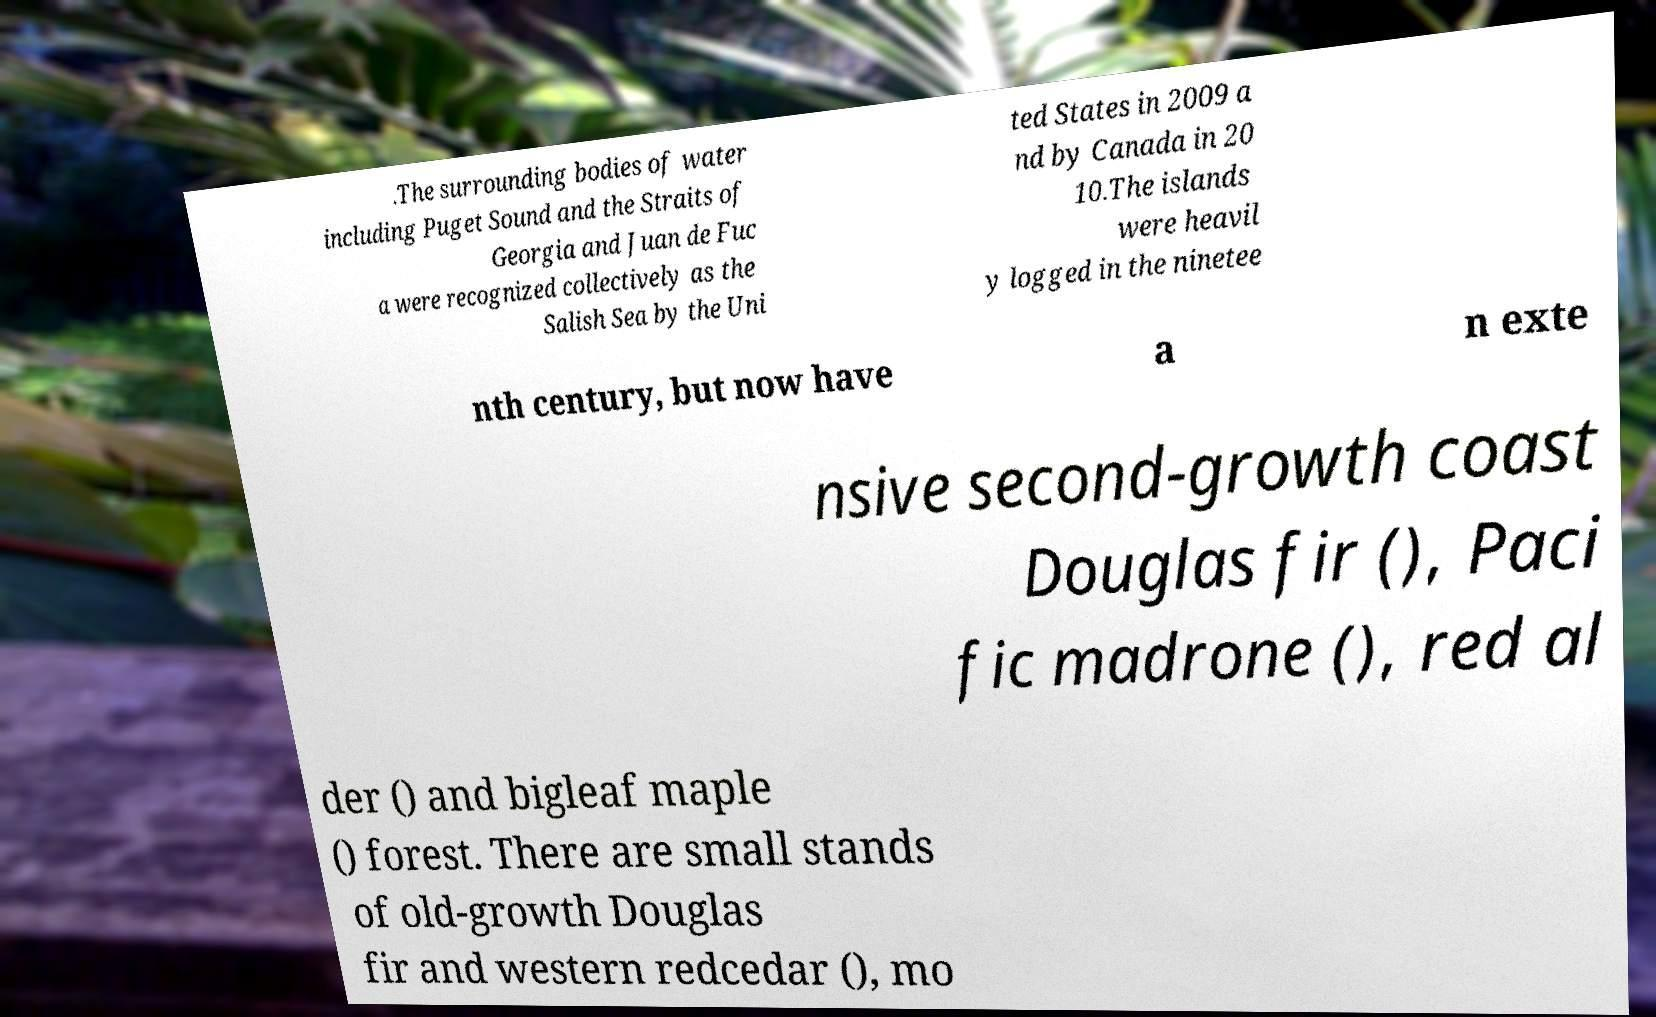For documentation purposes, I need the text within this image transcribed. Could you provide that? .The surrounding bodies of water including Puget Sound and the Straits of Georgia and Juan de Fuc a were recognized collectively as the Salish Sea by the Uni ted States in 2009 a nd by Canada in 20 10.The islands were heavil y logged in the ninetee nth century, but now have a n exte nsive second-growth coast Douglas fir (), Paci fic madrone (), red al der () and bigleaf maple () forest. There are small stands of old-growth Douglas fir and western redcedar (), mo 